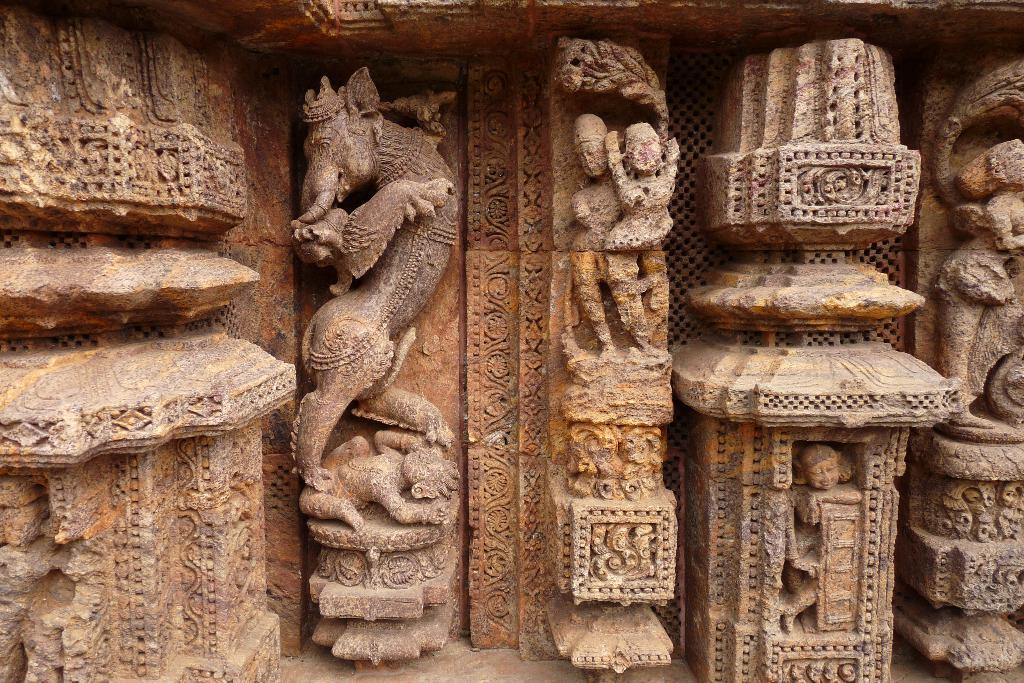What type of structure is depicted in the image? There is a historical temple wall in the image. What can be seen on the temple wall? The temple wall has sculptures. What is the color of the sculptures on the temple wall? The sculptures are brown in color. How many yaks are visible in the image? There are no yaks present in the image; it features a historical temple wall with sculptures. What is the size of the pie in the image? There is no pie present in the image. 